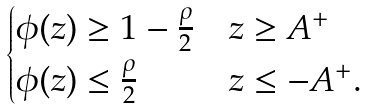<formula> <loc_0><loc_0><loc_500><loc_500>\begin{cases} \phi ( z ) \geq 1 - \frac { \rho } { 2 } & z \geq A ^ { + } \\ \phi ( z ) \leq \frac { \rho } { 2 } & z \leq - A ^ { + } . \end{cases}</formula> 